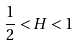Convert formula to latex. <formula><loc_0><loc_0><loc_500><loc_500>\frac { 1 } { 2 } < H < 1</formula> 